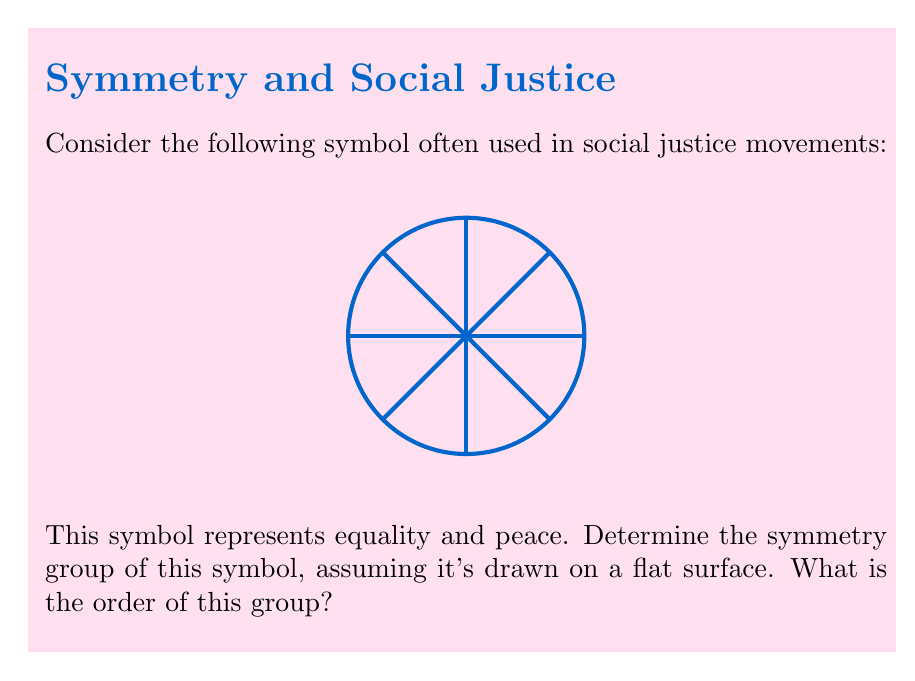Show me your answer to this math problem. Let's approach this step-by-step:

1) First, we need to identify all the symmetries of this symbol. A symmetry is a transformation that leaves the figure unchanged.

2) Rotational symmetries:
   - The symbol remains unchanged after rotations of 0°, 45°, 90°, 135°, 180°, 225°, 270°, and 315°.
   - That's 8 rotational symmetries in total.

3) Reflection symmetries:
   - The symbol has 4 lines of reflection: vertical, horizontal, and two diagonal lines.

4) The total number of symmetries is thus 8 (rotations) + 4 (reflections) = 12.

5) These symmetries form a group under composition. This group is isomorphic to the dihedral group $D_8$.

6) The dihedral group $D_8$ is defined as:

   $$D_8 = \langle r, s \mid r^8 = s^2 = 1, srs = r^{-1} \rangle$$

   where $r$ represents a rotation by 45° and $s$ represents a reflection.

7) The order of a group is the number of elements in the group. We've already determined that there are 12 symmetries in total.

Therefore, the symmetry group of this social justice symbol is $D_8$, and its order is 12.
Answer: $D_8$; order 12 